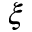<formula> <loc_0><loc_0><loc_500><loc_500>\xi</formula> 